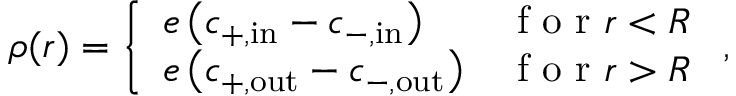<formula> <loc_0><loc_0><loc_500><loc_500>\rho ( r ) = \left \{ \begin{array} { l l } { e \left ( c _ { + , i n } - c _ { - , i n } \right ) } & { f o r r < R } \\ { e \left ( c _ { + , o u t } - c _ { - , o u t } \right ) } & { f o r r > R } \end{array} ,</formula> 